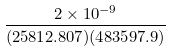Convert formula to latex. <formula><loc_0><loc_0><loc_500><loc_500>\frac { 2 \times 1 0 ^ { - 9 } } { ( 2 5 8 1 2 . 8 0 7 ) ( 4 8 3 5 9 7 . 9 ) }</formula> 